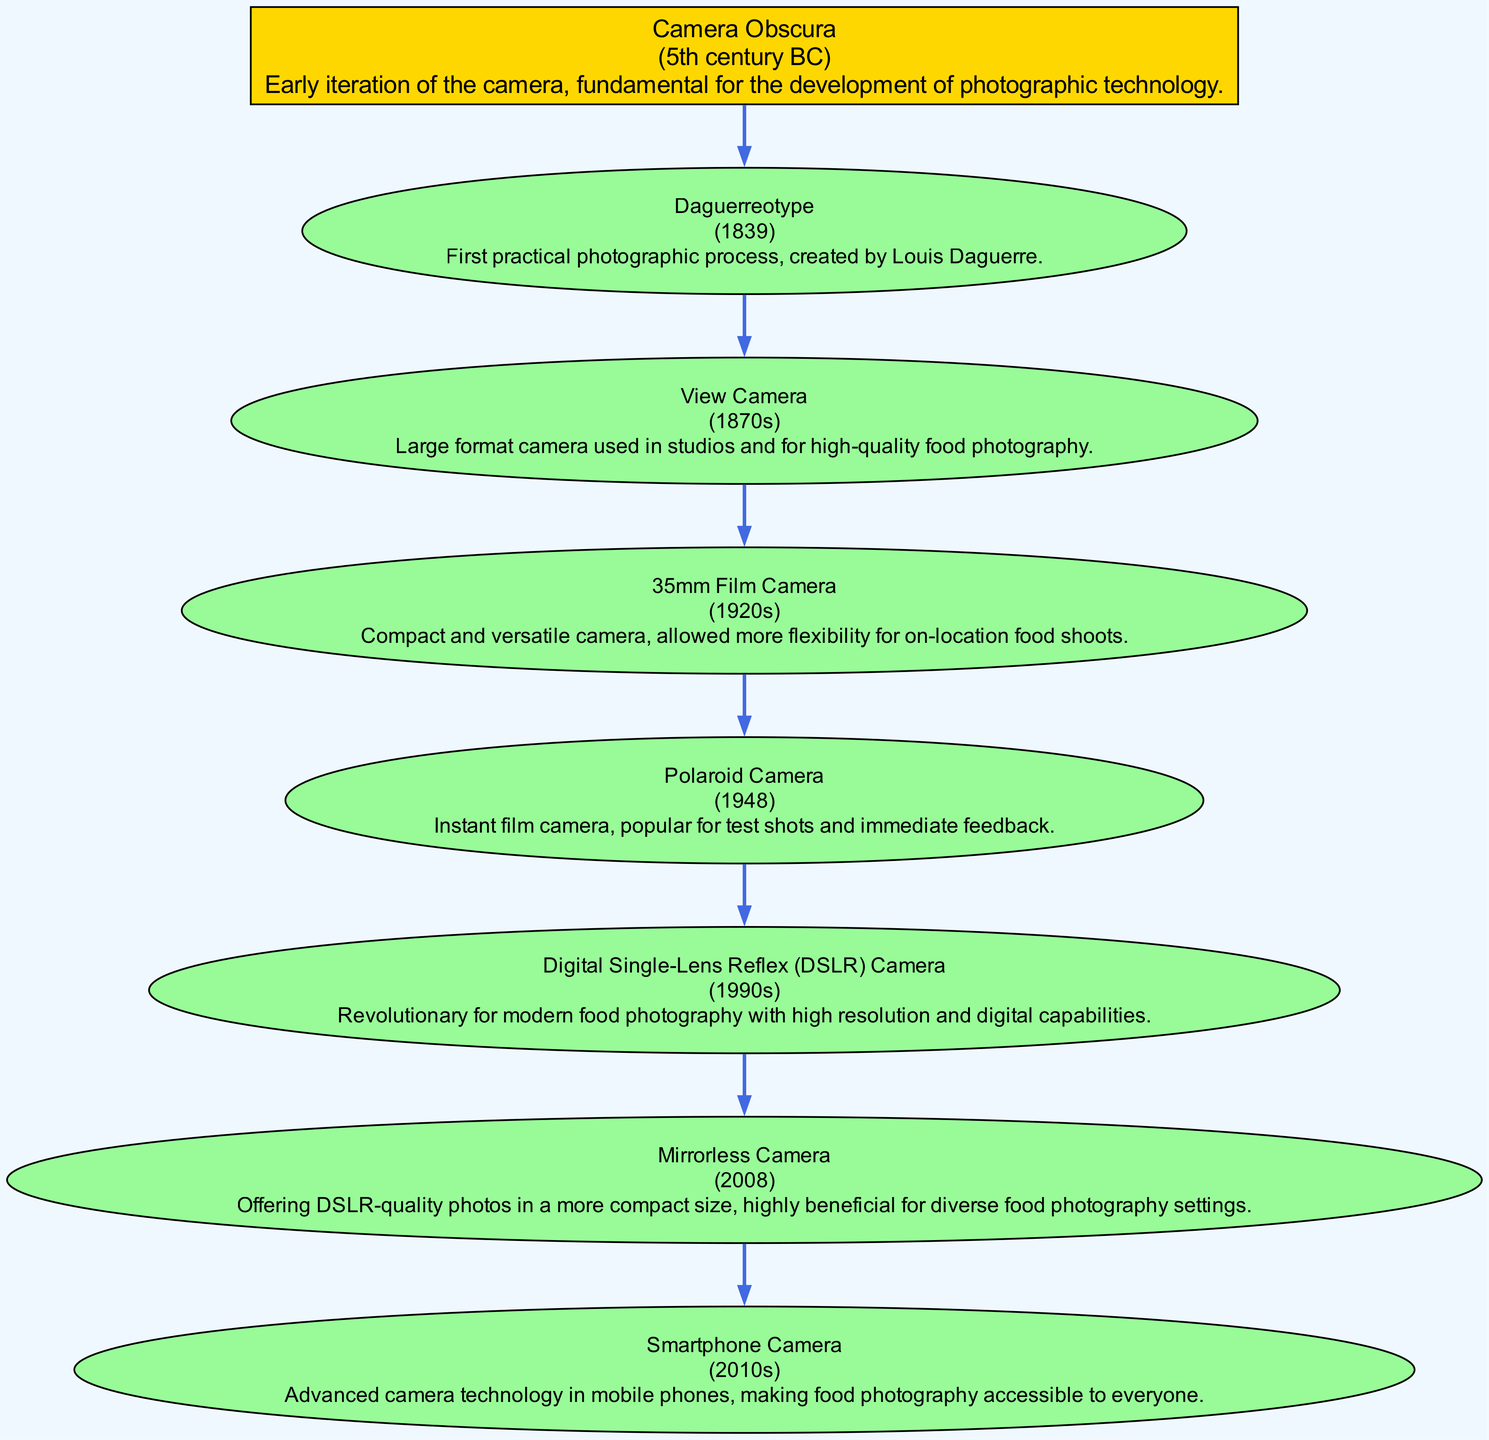What is the earliest camera technology represented in the diagram? The diagram starts with "Camera Obscura," which is positioned at the top as the ancestor in the family tree, indicating it is the earliest technology.
Answer: Camera Obscura What is the most recent camera technology shown? The last node in the diagram is "Smartphone Camera," positioned at the bottom, which indicates it is the most recent development in the family tree's timeline.
Answer: Smartphone Camera How many generations of camera technology are represented in the diagram? By counting the number of different generations starting from the ancestor, there are eight distinct generations, with each technological advancement categorized under a generation number.
Answer: 8 Which camera technology was introduced in the 1830s? Looking at the date associated with the "Daguerreotype" node, it shows 1839, which places this technology in that decade as the first practical photographic process.
Answer: Daguerreotype What is the relationship between the "Polaroid Camera" and "Digital Single-Lens Reflex (DSLR) Camera"? The "Polaroid Camera" is connected to the "Digital Single-Lens Reflex (DSLR) Camera" through the previous generation of camera technologies. Specifically, the DSLRs came after Polaroid, showing an evolution towards digital photography.
Answer: Descendant Which camera introduced instant film technology? The "Polaroid Camera" is specifically known for its instant film technology, which is highlighted in its description within the diagram.
Answer: Polaroid Camera What type of camera is known for being compact and versatile for on-location food photography? Referring to the description of the "35mm Film Camera," it is noted for its compact nature and versatility, which are key features for food photography in various locations.
Answer: 35mm Film Camera From which technology did the “Mirrorless Camera” evolve? The "Mirrorless Camera" technology is a descendant of the "Digital Single-Lens Reflex (DSLR) Camera," which indicates a technological evolution from DSLRs to mirrorless options.
Answer: Digital Single-Lens Reflex (DSLR) Camera 